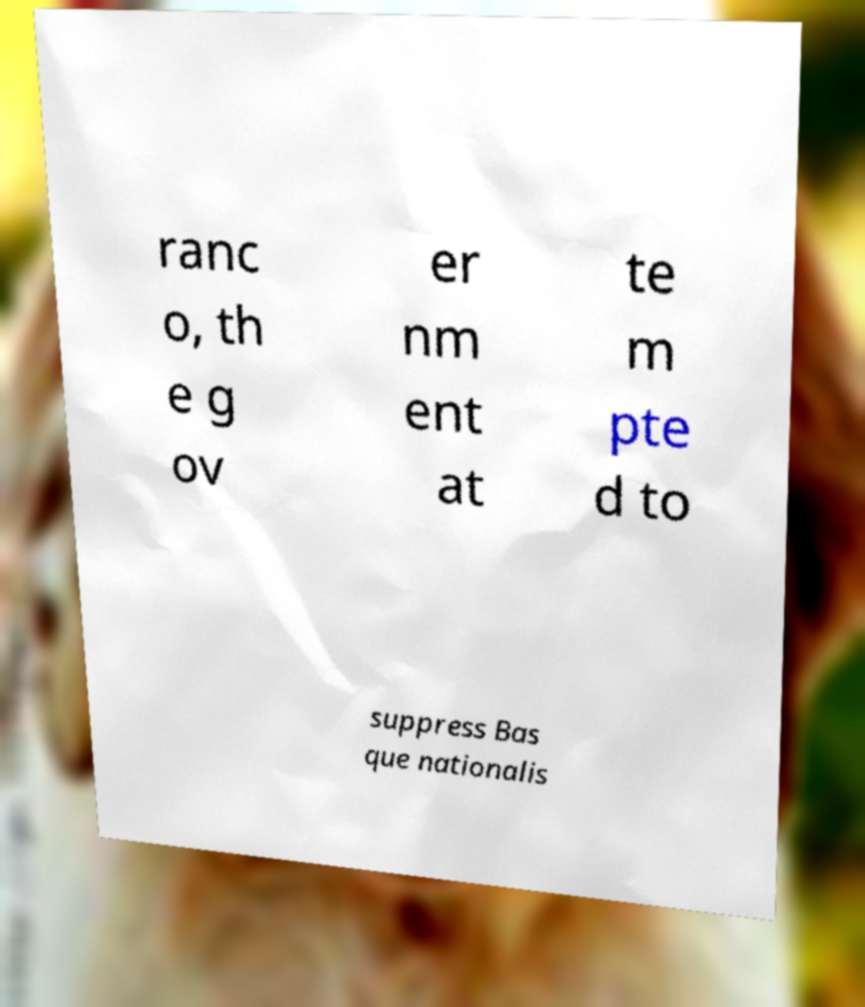For documentation purposes, I need the text within this image transcribed. Could you provide that? ranc o, th e g ov er nm ent at te m pte d to suppress Bas que nationalis 